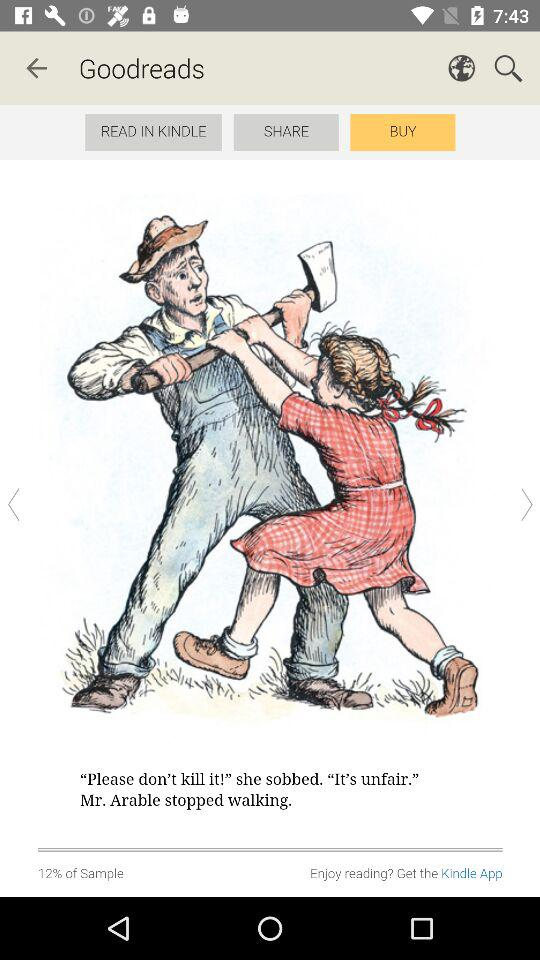What is the percentage of people who have read this book?
Answer the question using a single word or phrase. 12% 